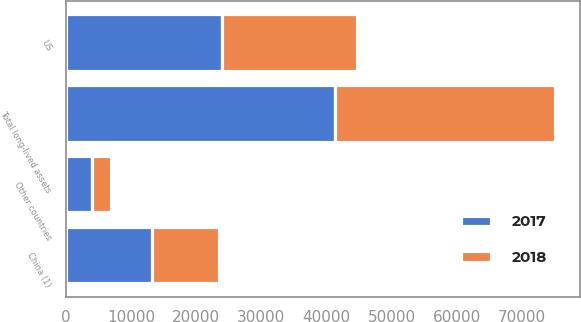<chart> <loc_0><loc_0><loc_500><loc_500><stacked_bar_chart><ecel><fcel>US<fcel>China (1)<fcel>Other countries<fcel>Total long-lived assets<nl><fcel>2017<fcel>23963<fcel>13268<fcel>4073<fcel>41304<nl><fcel>2018<fcel>20637<fcel>10211<fcel>2935<fcel>33783<nl></chart> 